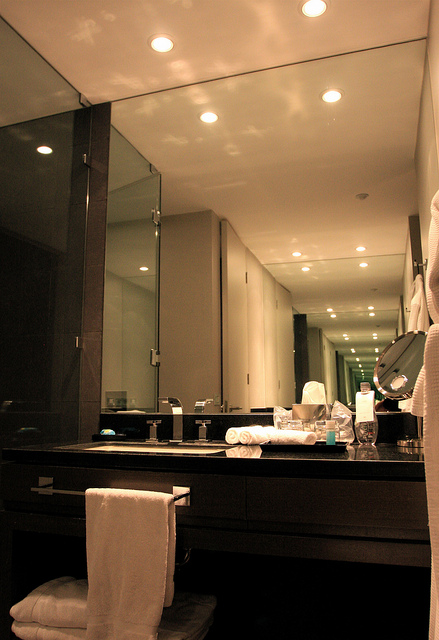How does the presence of a large mirror in the bathroom contribute to its overall design and functionality? The presence of a large mirror in the bathroom significantly enhances both its design and functionality. It amplifies the sense of space, making the room feel larger and more open due to the reflection of light. This reflection not only improves the brightness and ambiance, creating a welcoming environment, but also adds a touch of modern elegance. Functionally, the mirror provides ample viewing space for daily grooming tasks such as brushing teeth, applying makeup, and shaving, catering to the practical needs of the users. Furthermore, it complements the contemporary decor of the bathroom, contributing to a cohesive and stylish aesthetic. 